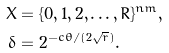Convert formula to latex. <formula><loc_0><loc_0><loc_500><loc_500>X & = \{ 0 , 1 , 2 , \dots , R \} ^ { n m } , \\ \delta & = 2 ^ { - c \theta / ( 2 \sqrt { r } ) } .</formula> 